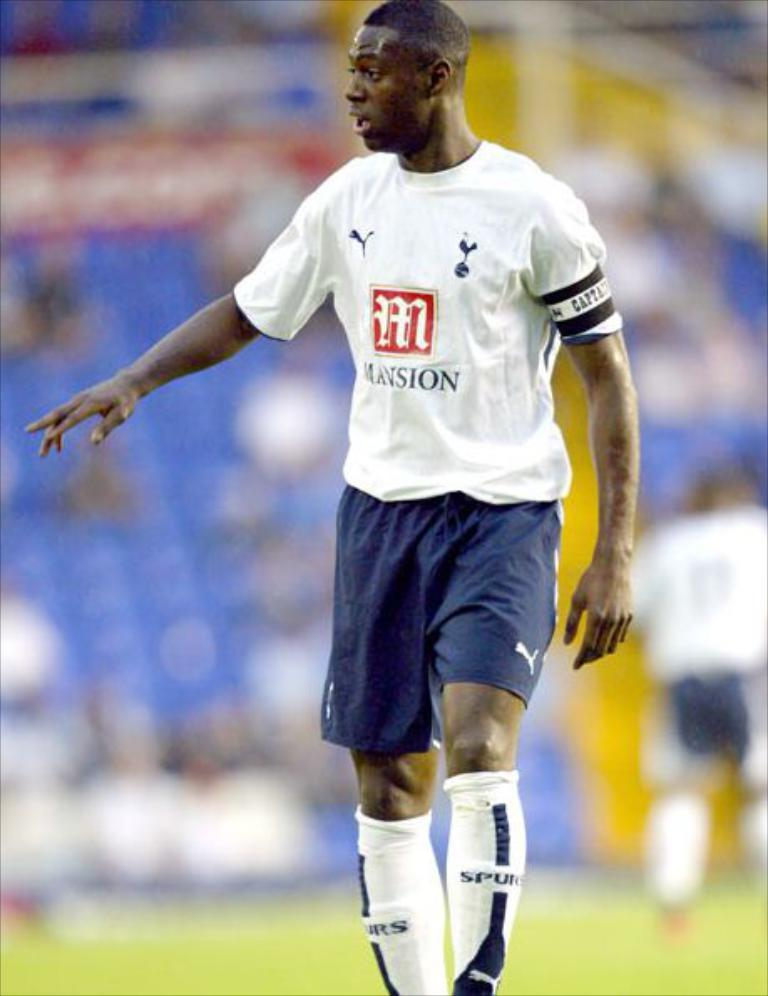What is the main subject of the image? The main subject of the image is a player. What is the player wearing? The player is wearing a white t-shirt and blue shorts. Where is the player standing? The player is standing on a ground. How would you describe the background of the image? The background of the image is blurred. What type of rhythm is the player following in the image? There is no indication of rhythm or any musical activity in the image; the player is simply standing on a ground. 